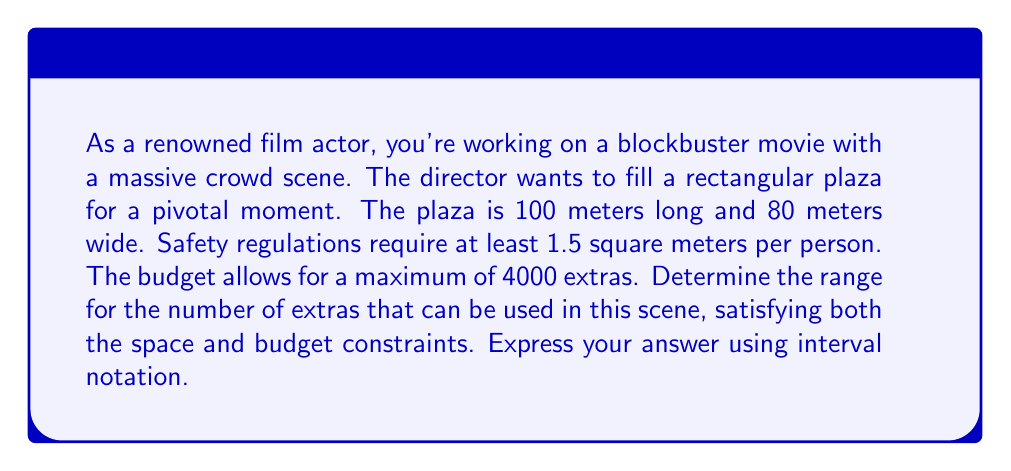Provide a solution to this math problem. Let's approach this step-by-step:

1) First, let's calculate the total area of the plaza:
   Area = length × width
   $$ A = 100 \text{ m} \times 80 \text{ m} = 8000 \text{ m}^2 $$

2) Now, let's consider the space constraint. Each person needs at least 1.5 square meters:
   $$ \frac{\text{Total Area}}{\text{Area per person}} \geq \text{Number of extras} $$
   $$ \frac{8000 \text{ m}^2}{1.5 \text{ m}^2/\text{person}} \geq x $$
   $$ 5333.33 \geq x $$

3) Since we can't have a fractional number of people, we round down:
   $$ x \leq 5333 $$

4) Now, let's consider the budget constraint:
   $$ x \leq 4000 $$

5) Combining both constraints:
   $$ x \leq 4000 \text{ (budget constraint)} $$
   $$ x \geq 1 \text{ (we need at least one extra)} $$

6) Therefore, the number of extras (x) must satisfy:
   $$ 1 \leq x \leq 4000 $$

7) In interval notation, this is written as [1, 4000].
Answer: [1, 4000] 